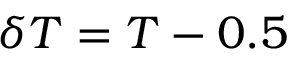<formula> <loc_0><loc_0><loc_500><loc_500>\delta T = T - 0 . 5</formula> 